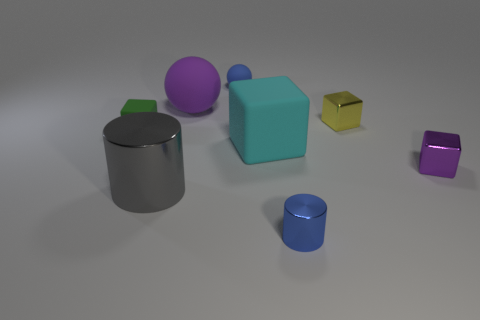Do the purple matte sphere and the gray object have the same size?
Keep it short and to the point. Yes. There is a blue object that is behind the small blue cylinder in front of the yellow shiny block; what size is it?
Your answer should be very brief. Small. There is a thing that is both left of the purple matte ball and behind the purple shiny thing; what is its size?
Provide a succinct answer. Small. What number of green blocks have the same size as the purple shiny cube?
Give a very brief answer. 1. How many rubber objects are either large cylinders or blue cylinders?
Ensure brevity in your answer.  0. What material is the small blue thing that is left of the tiny blue thing in front of the large shiny cylinder made of?
Make the answer very short. Rubber. How many objects are blue spheres or blue objects in front of the blue rubber thing?
Your answer should be very brief. 2. The gray object that is the same material as the yellow cube is what size?
Your answer should be compact. Large. How many gray objects are either small shiny balls or cylinders?
Keep it short and to the point. 1. There is a metallic object that is the same color as the big ball; what shape is it?
Ensure brevity in your answer.  Cube. 